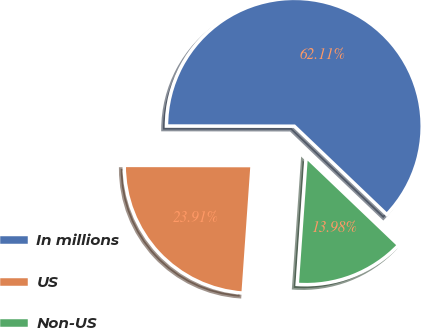Convert chart. <chart><loc_0><loc_0><loc_500><loc_500><pie_chart><fcel>In millions<fcel>US<fcel>Non-US<nl><fcel>62.11%<fcel>23.91%<fcel>13.98%<nl></chart> 